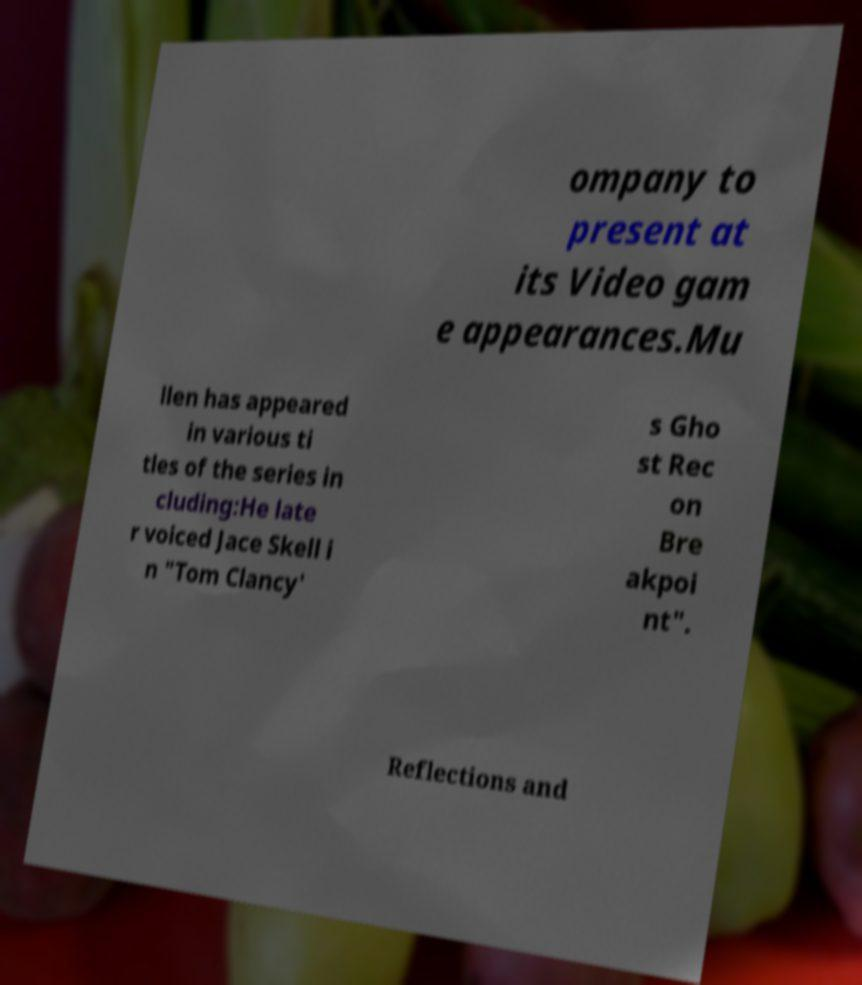Please read and relay the text visible in this image. What does it say? ompany to present at its Video gam e appearances.Mu llen has appeared in various ti tles of the series in cluding:He late r voiced Jace Skell i n "Tom Clancy' s Gho st Rec on Bre akpoi nt". Reflections and 